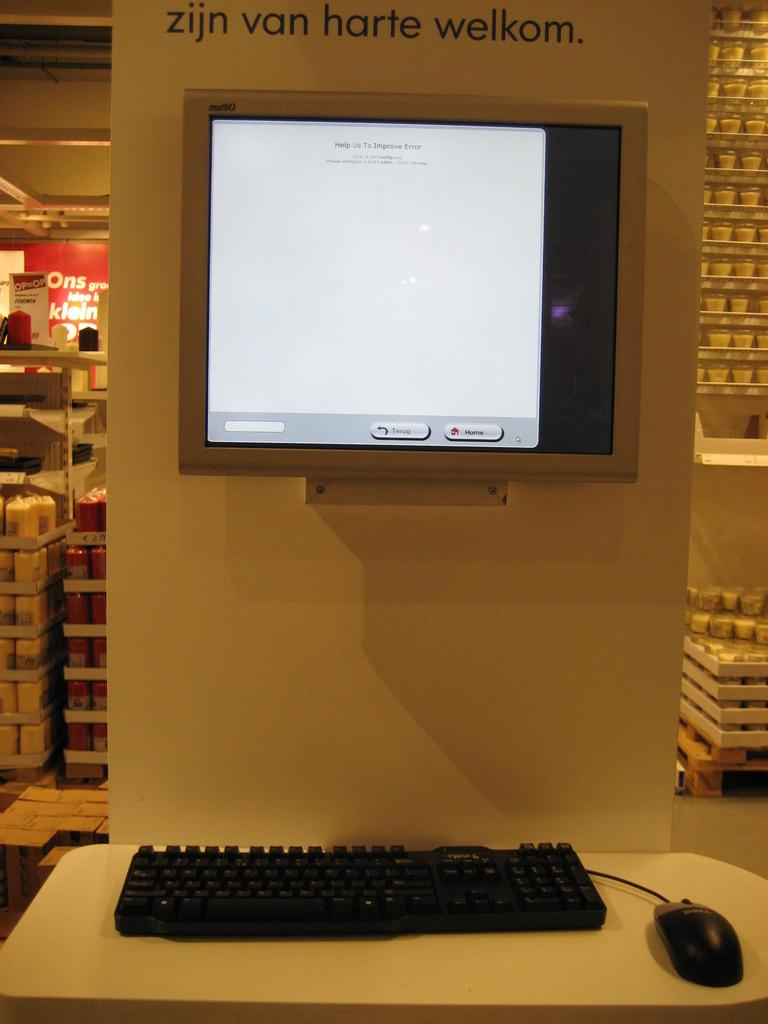<image>
Give a short and clear explanation of the subsequent image. zijn van harte welkom monitor on the wall with a keyboard and mouse 